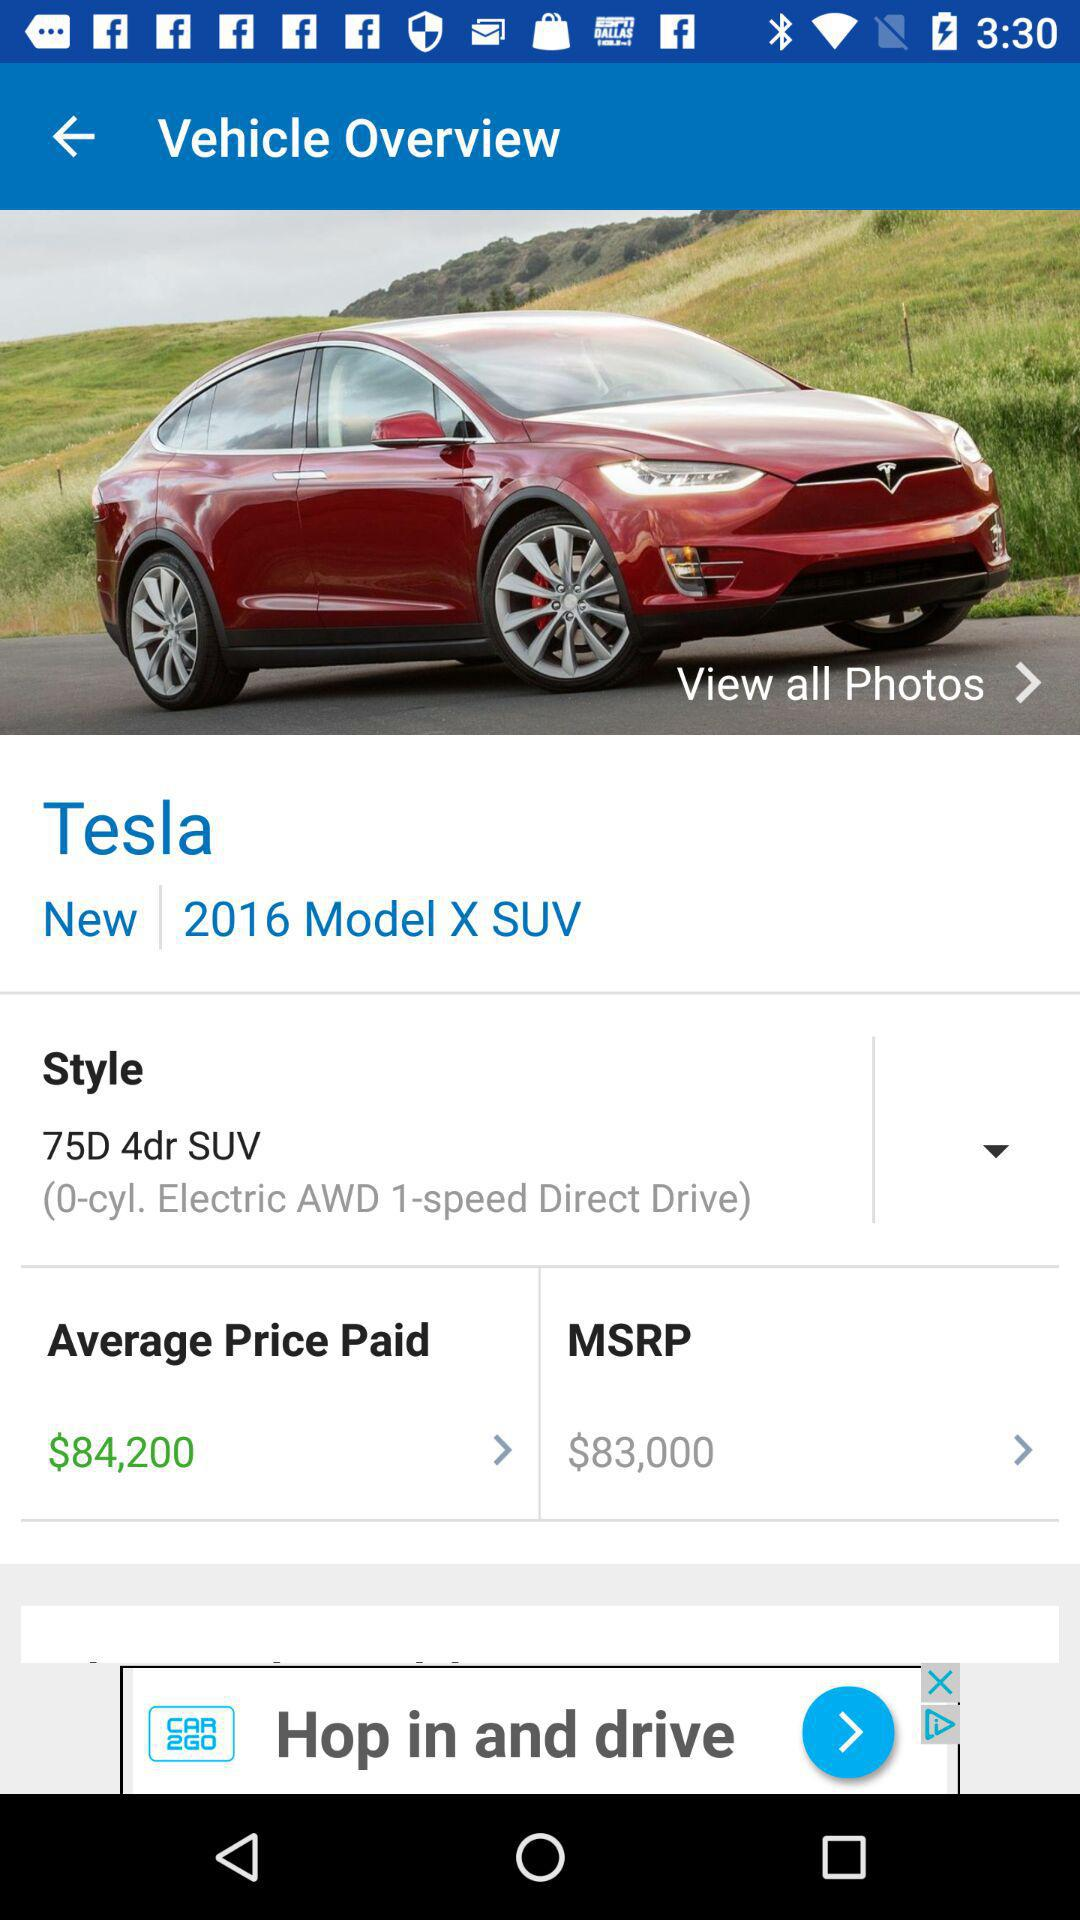How much is the MSRP of this vehicle?
Answer the question using a single word or phrase. $83,000 